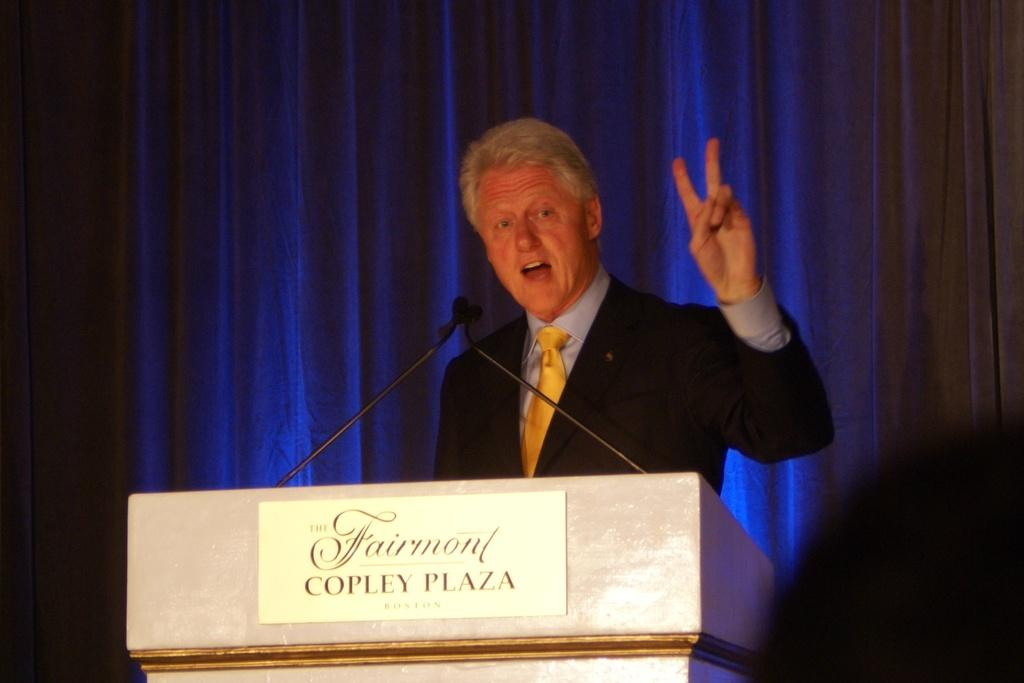<image>
Summarize the visual content of the image. Bill Clinton holding up a peace sign behind the podium that reads Fairmont Copley Plaza. 